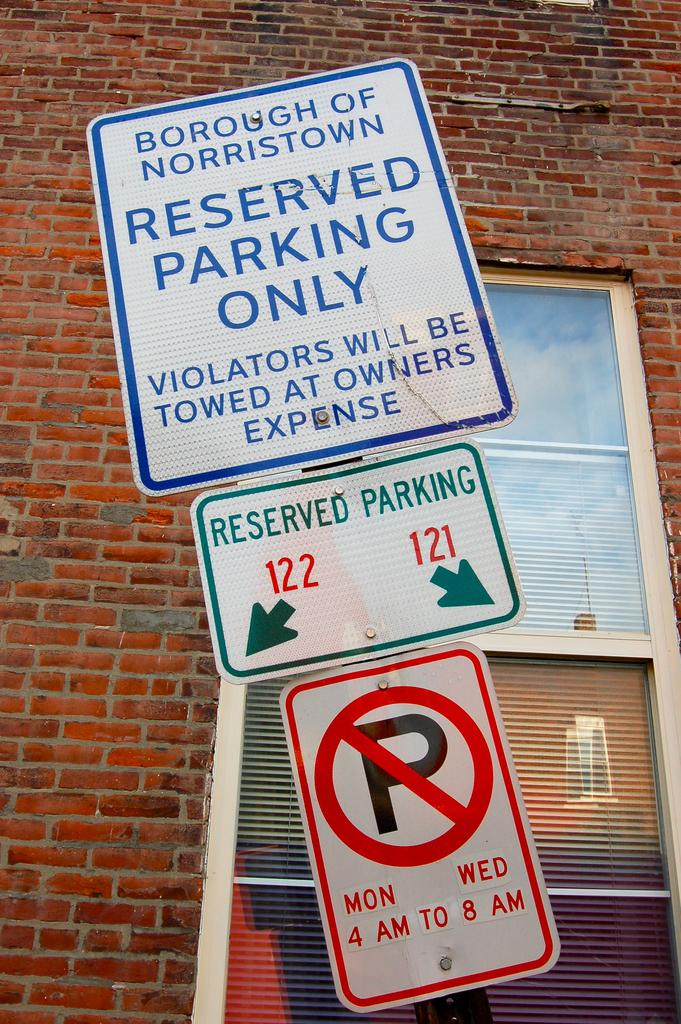Provide a one-sentence caption for the provided image. A sign on a pole before a building stresses greatly that the parking is for reserved people only. 